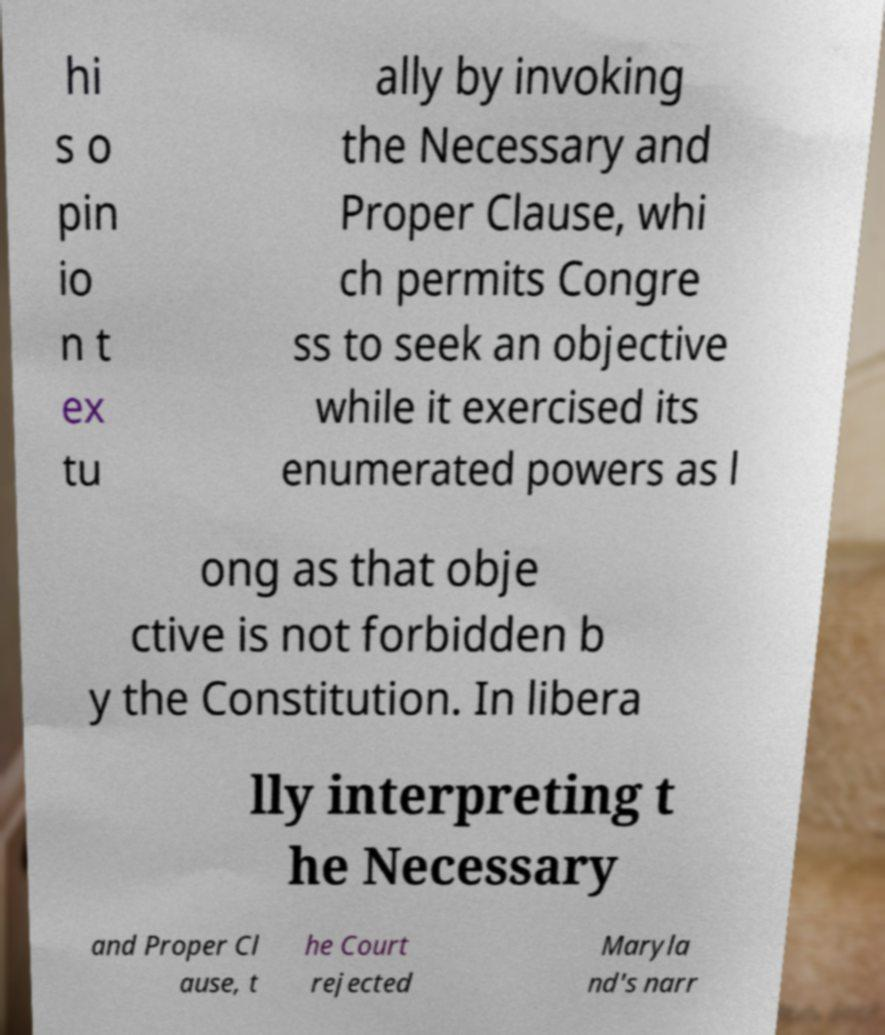Can you read and provide the text displayed in the image?This photo seems to have some interesting text. Can you extract and type it out for me? hi s o pin io n t ex tu ally by invoking the Necessary and Proper Clause, whi ch permits Congre ss to seek an objective while it exercised its enumerated powers as l ong as that obje ctive is not forbidden b y the Constitution. In libera lly interpreting t he Necessary and Proper Cl ause, t he Court rejected Maryla nd's narr 